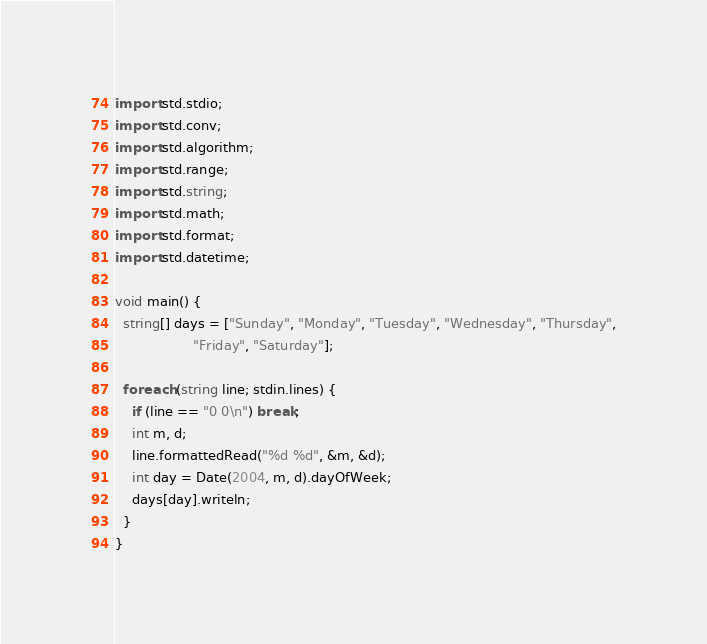Convert code to text. <code><loc_0><loc_0><loc_500><loc_500><_D_>import std.stdio;
import std.conv;
import std.algorithm;
import std.range;
import std.string;
import std.math;
import std.format;
import std.datetime;

void main() {
  string[] days = ["Sunday", "Monday", "Tuesday", "Wednesday", "Thursday",
                   "Friday", "Saturday"];

  foreach (string line; stdin.lines) {
    if (line == "0 0\n") break;
    int m, d;
    line.formattedRead("%d %d", &m, &d);
    int day = Date(2004, m, d).dayOfWeek;
    days[day].writeln;
  }
}</code> 